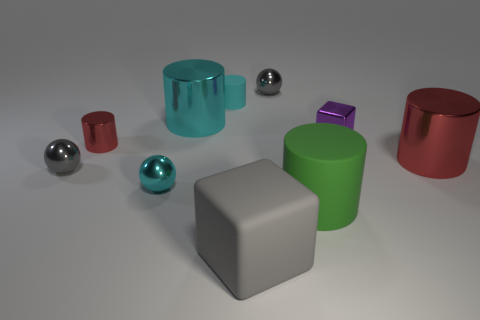Subtract all red metallic cylinders. How many cylinders are left? 3 Subtract all red cylinders. How many cylinders are left? 3 Subtract 2 spheres. How many spheres are left? 1 Subtract all cubes. How many objects are left? 8 Subtract all cyan balls. Subtract all red cubes. How many balls are left? 2 Subtract all yellow cylinders. How many green blocks are left? 0 Subtract all large cyan matte spheres. Subtract all big green cylinders. How many objects are left? 9 Add 9 small matte cylinders. How many small matte cylinders are left? 10 Add 9 rubber blocks. How many rubber blocks exist? 10 Subtract 0 yellow cylinders. How many objects are left? 10 